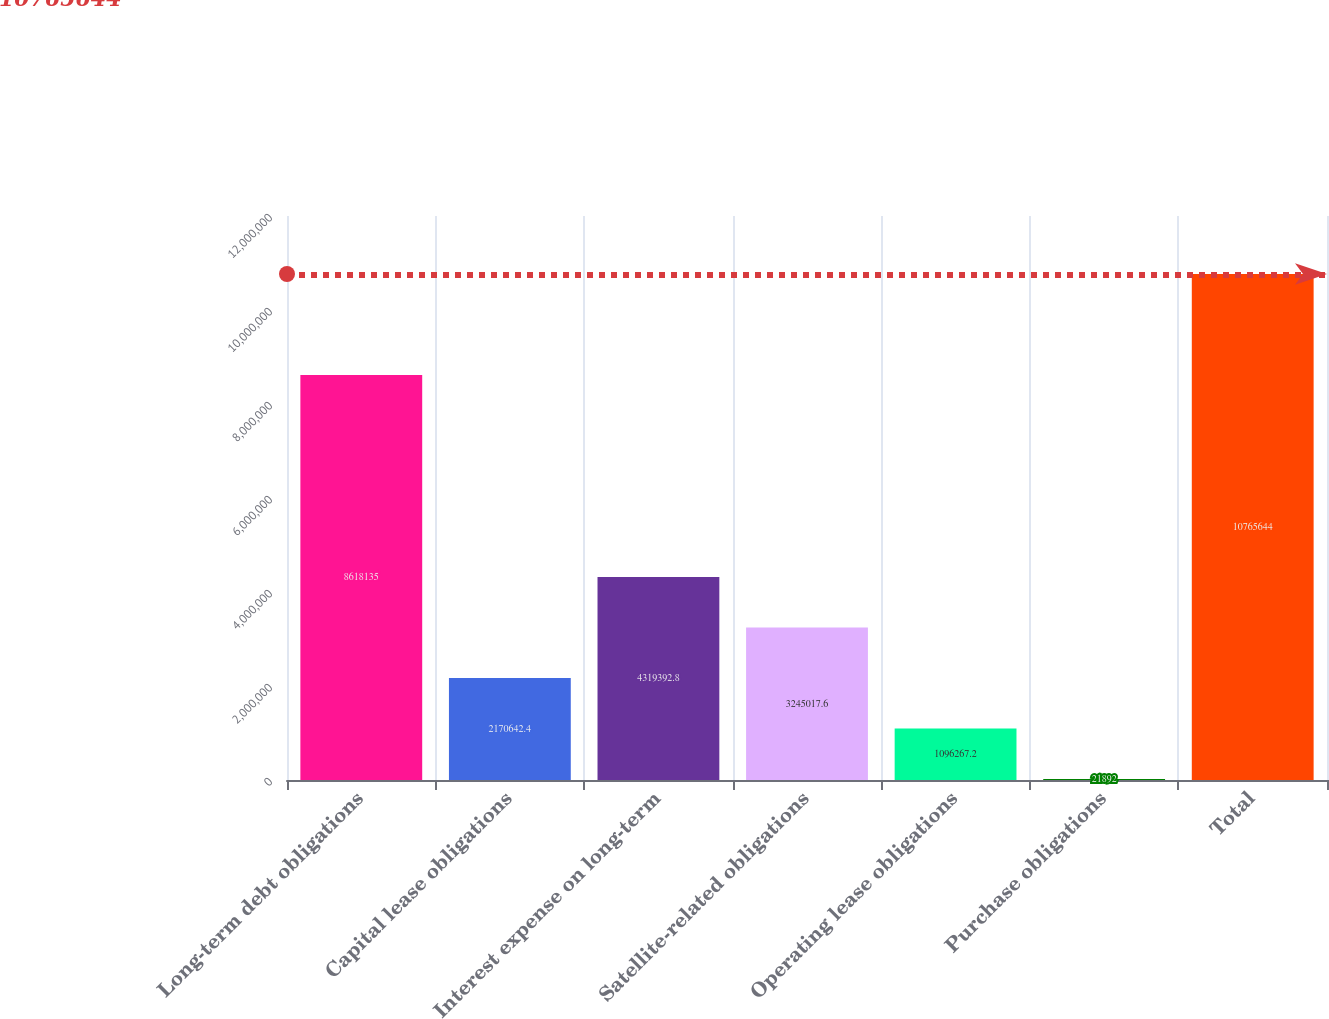Convert chart to OTSL. <chart><loc_0><loc_0><loc_500><loc_500><bar_chart><fcel>Long-term debt obligations<fcel>Capital lease obligations<fcel>Interest expense on long-term<fcel>Satellite-related obligations<fcel>Operating lease obligations<fcel>Purchase obligations<fcel>Total<nl><fcel>8.61814e+06<fcel>2.17064e+06<fcel>4.31939e+06<fcel>3.24502e+06<fcel>1.09627e+06<fcel>21892<fcel>1.07656e+07<nl></chart> 